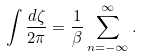Convert formula to latex. <formula><loc_0><loc_0><loc_500><loc_500>\int \frac { d \zeta } { 2 \pi } = \frac { 1 } { \beta } \sum _ { n = - \infty } ^ { \infty } .</formula> 